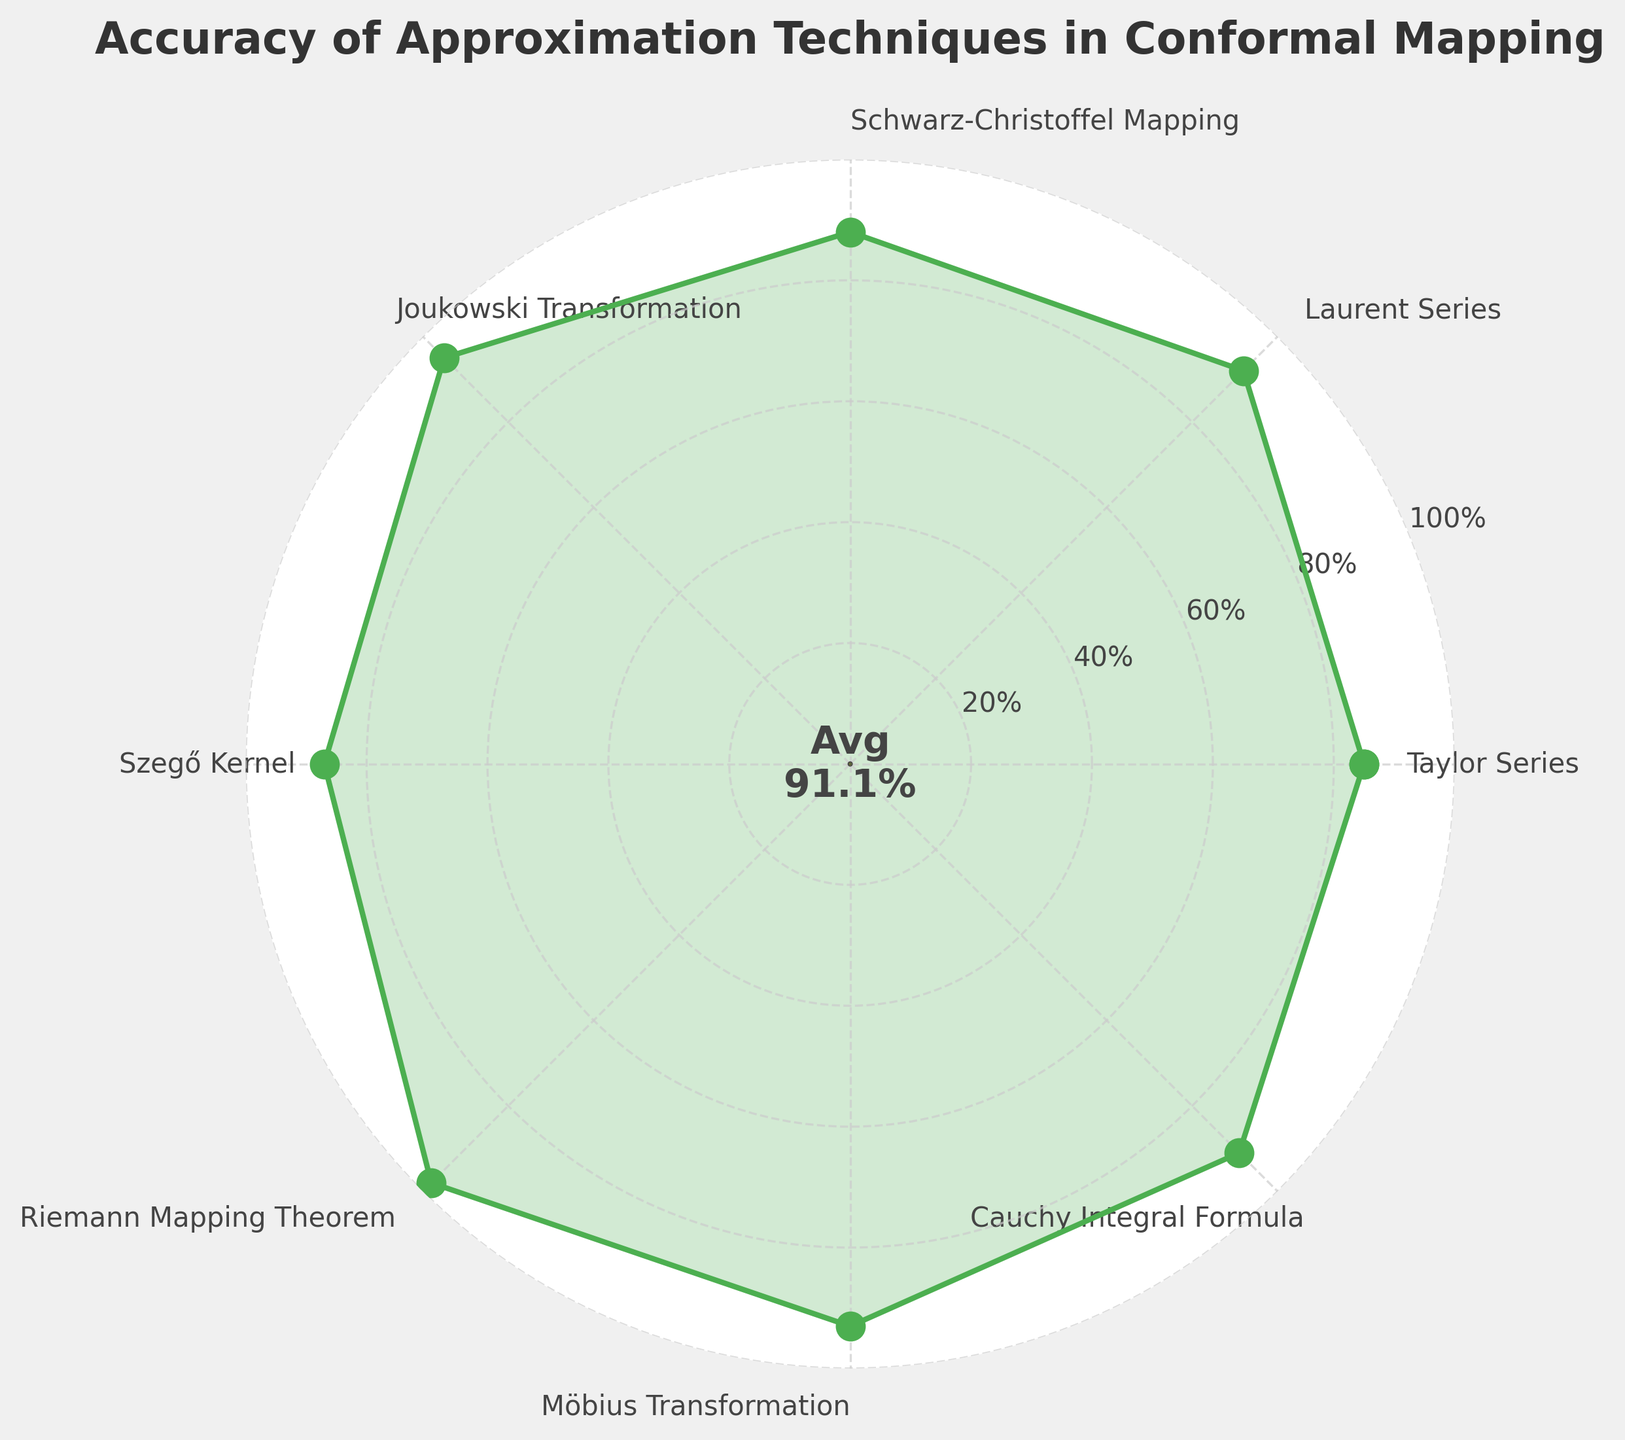Which technique has the highest accuracy? The Riemann Mapping Theorem has the highest accuracy, which surpasses all other techniques. The visual representation at the top confirms this.
Answer: Riemann Mapping Theorem What is the average accuracy of all techniques? To find the average, sum all accuracy values: 85 + 92 + 88 + 95 + 87 + 98 + 93 + 91 = 729. Then divide by the number of techniques, which is 8: 729 / 8 = 91.125.
Answer: 91.1% Which method has a lower accuracy than the Möbius Transformation? The methods with accuracies lower than the Möbius Transformation (93%) are Taylor Series (85%), Schwarz-Christoffel Mapping (88%), Szegő Kernel (87%), and Cauchy Integral Formula (91%).
Answer: Taylor Series, Schwarz-Christoffel Mapping, Szegő Kernel, Cauchy Integral Formula Is the accuracy range covered in this plot wide or narrow? The range is found by subtracting the minimum accuracy (85%) from the maximum accuracy (98%). Therefore, 98 - 85 = 13%. This indicates a narrow range as the span is only 13%.
Answer: Narrow How does the accuracy of the Joukowski Transformation compare to the Schwarz-Christoffel Mapping? The accuracy of the Joukowski Transformation is 95%, which is higher than the 88% accuracy of the Schwarz-Christoffel Mapping.
Answer: Joukowski Transformation is higher What percentile accuracy is represented by the technique with the median value? To find the median, list the accuracies in order: 85, 87, 88, 91, 92, 93, 95, 98. The median is the average of the 4th and 5th numbers (91 and 92): (91 + 92) / 2 = 91.5%.
Answer: 91.5% Which methods have an accuracy of 90% or above? The methods with accuracies of 90% or above are: Riemann Mapping Theorem (98%), Möbius Transformation (93%), Joukowski Transformation (95%), Cauchy Integral Formula (91%), and Laurent Series (92%).
Answer: Riemann Mapping Theorem, Möbius Transformation, Joukowski Transformation, Cauchy Integral Formula, Laurent Series Are most techniques clustered around similar accuracy levels or spread out? Most techniques have accuracies between 85% and 98%, with many around the 90-95% range based on the visual representation on the gauge chart. This indicates that they are relatively clustered.
Answer: Clustered What fraction of the techniques has an accuracy above the average accuracy identified? The average accuracy is approximately 91.1%. The techniques above this are: Laurent Series (92%), Joukowski Transformation (95%), Riemann Mapping Theorem (98%), and Möbius Transformation (93%). There are 4 techniques above average out of 8 total. Therefore, the fraction is 4/8 = 1/2 or 50%.
Answer: 50% 